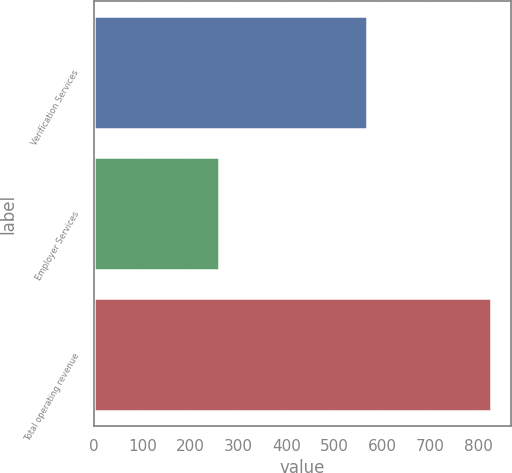Convert chart to OTSL. <chart><loc_0><loc_0><loc_500><loc_500><bar_chart><fcel>Verification Services<fcel>Employer Services<fcel>Total operating revenue<nl><fcel>567<fcel>259.8<fcel>826.8<nl></chart> 